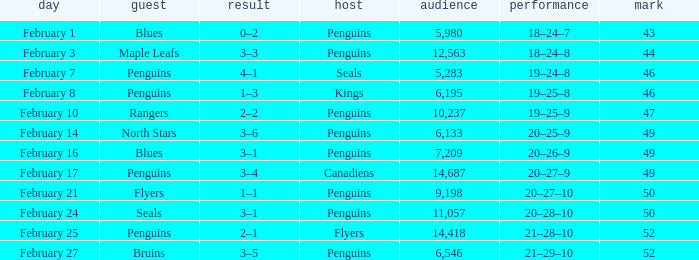Score of 2–1 has what record? 21–28–10. 